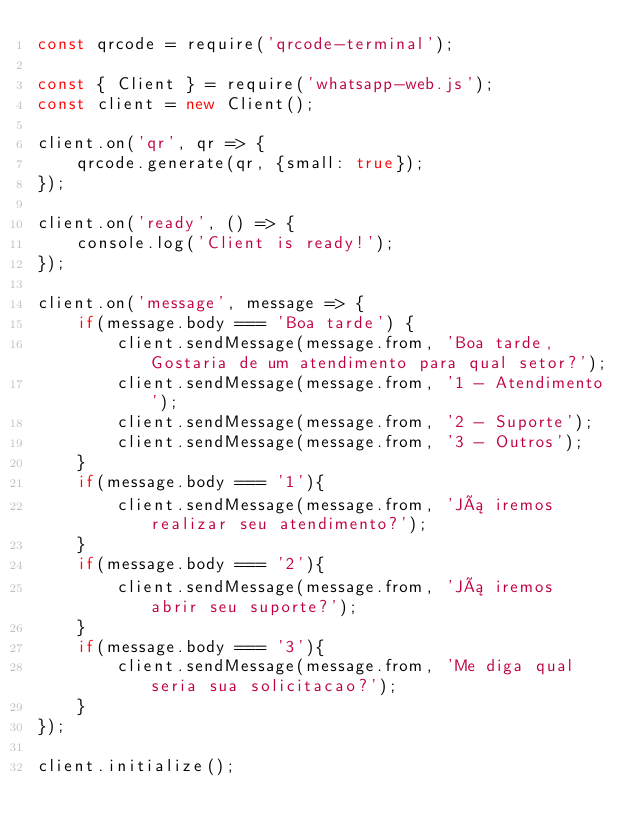Convert code to text. <code><loc_0><loc_0><loc_500><loc_500><_JavaScript_>const qrcode = require('qrcode-terminal');

const { Client } = require('whatsapp-web.js');
const client = new Client();

client.on('qr', qr => {
    qrcode.generate(qr, {small: true});
});

client.on('ready', () => {
    console.log('Client is ready!');
});

client.on('message', message => {
    if(message.body === 'Boa tarde') {
        client.sendMessage(message.from, 'Boa tarde, Gostaria de um atendimento para qual setor?');
        client.sendMessage(message.from, '1 - Atendimento');
        client.sendMessage(message.from, '2 - Suporte');
        client.sendMessage(message.from, '3 - Outros');
    }
    if(message.body === '1'){
        client.sendMessage(message.from, 'Já iremos realizar seu atendimento?');
    }
    if(message.body === '2'){
        client.sendMessage(message.from, 'Já iremos abrir seu suporte?');
    }
    if(message.body === '3'){
        client.sendMessage(message.from, 'Me diga qual seria sua solicitacao?');
    }
});

client.initialize();</code> 